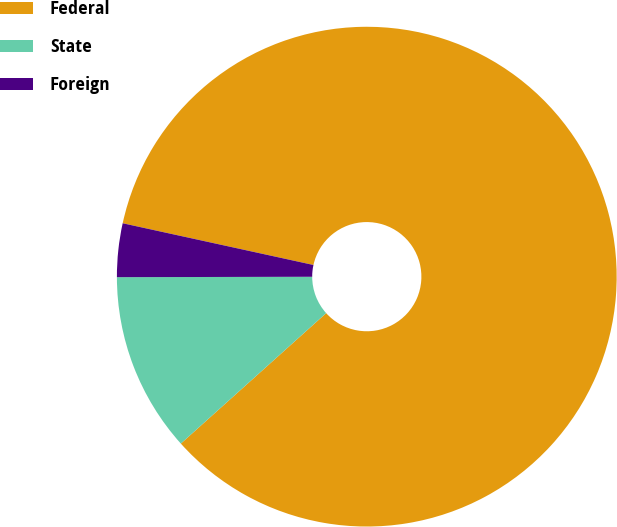Convert chart. <chart><loc_0><loc_0><loc_500><loc_500><pie_chart><fcel>Federal<fcel>State<fcel>Foreign<nl><fcel>84.93%<fcel>11.61%<fcel>3.46%<nl></chart> 